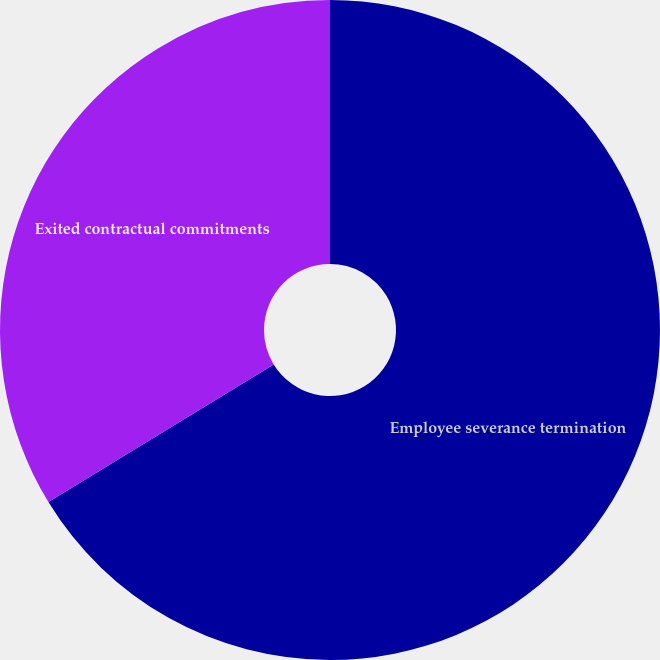Convert chart. <chart><loc_0><loc_0><loc_500><loc_500><pie_chart><fcel>Employee severance termination<fcel>Exited contractual commitments<nl><fcel>66.27%<fcel>33.73%<nl></chart> 